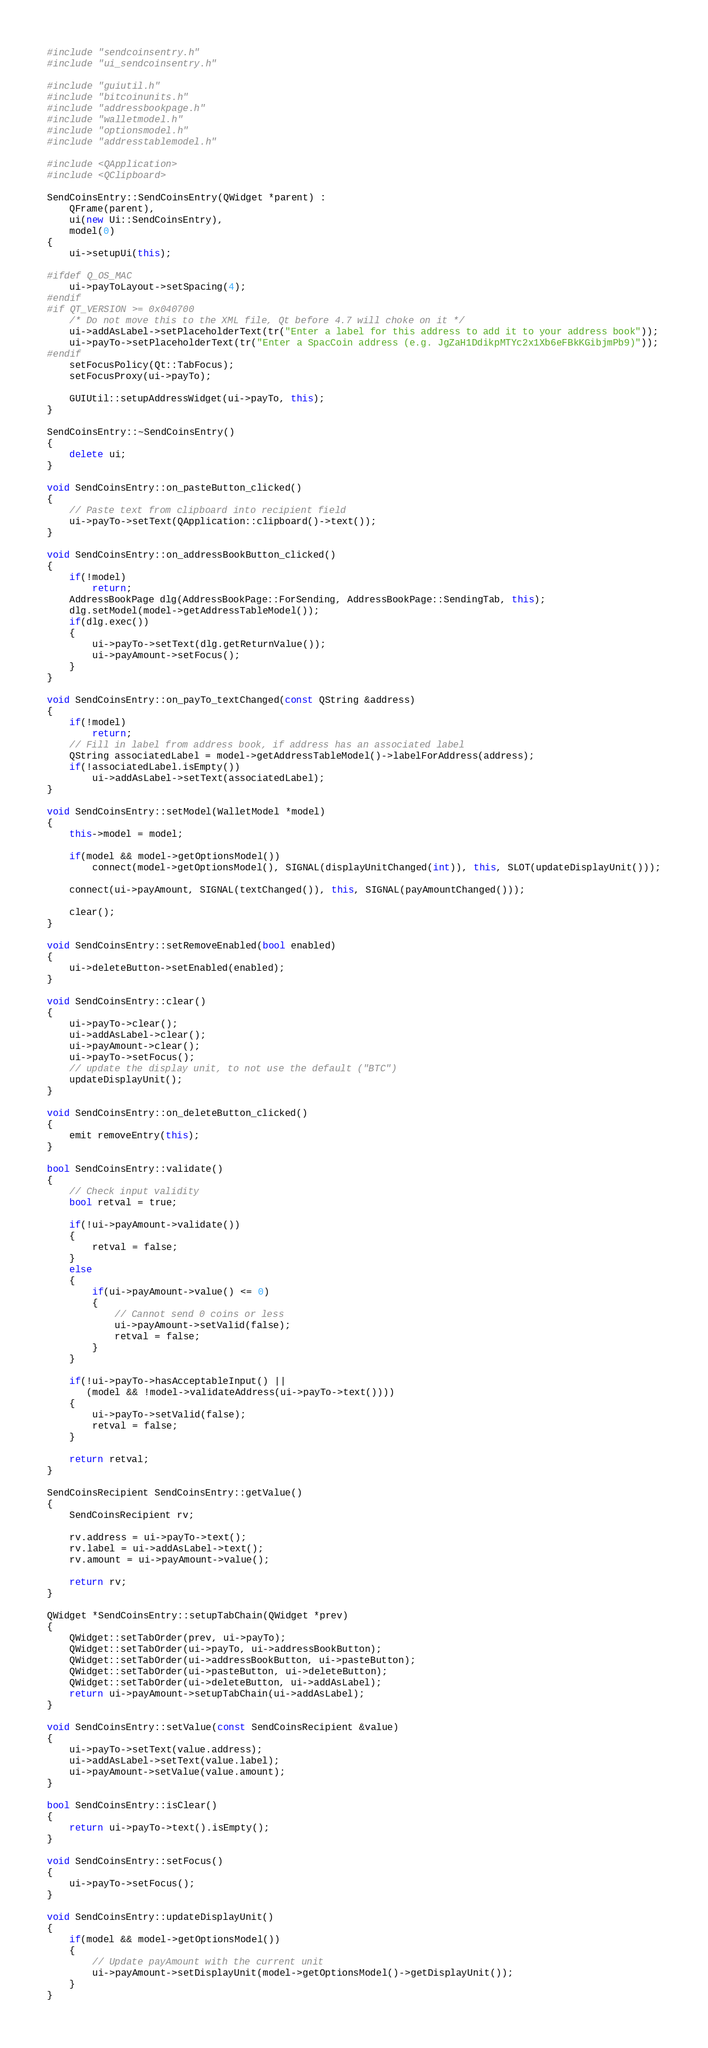Convert code to text. <code><loc_0><loc_0><loc_500><loc_500><_C++_>#include "sendcoinsentry.h"
#include "ui_sendcoinsentry.h"

#include "guiutil.h"
#include "bitcoinunits.h"
#include "addressbookpage.h"
#include "walletmodel.h"
#include "optionsmodel.h"
#include "addresstablemodel.h"

#include <QApplication>
#include <QClipboard>

SendCoinsEntry::SendCoinsEntry(QWidget *parent) :
    QFrame(parent),
    ui(new Ui::SendCoinsEntry),
    model(0)
{
    ui->setupUi(this);

#ifdef Q_OS_MAC
    ui->payToLayout->setSpacing(4);
#endif
#if QT_VERSION >= 0x040700
    /* Do not move this to the XML file, Qt before 4.7 will choke on it */
    ui->addAsLabel->setPlaceholderText(tr("Enter a label for this address to add it to your address book"));
    ui->payTo->setPlaceholderText(tr("Enter a SpacCoin address (e.g. JgZaH1DdikpMTYc2x1Xb6eFBkKGibjmPb9)"));
#endif
    setFocusPolicy(Qt::TabFocus);
    setFocusProxy(ui->payTo);

    GUIUtil::setupAddressWidget(ui->payTo, this);
}

SendCoinsEntry::~SendCoinsEntry()
{
    delete ui;
}

void SendCoinsEntry::on_pasteButton_clicked()
{
    // Paste text from clipboard into recipient field
    ui->payTo->setText(QApplication::clipboard()->text());
}

void SendCoinsEntry::on_addressBookButton_clicked()
{
    if(!model)
        return;
    AddressBookPage dlg(AddressBookPage::ForSending, AddressBookPage::SendingTab, this);
    dlg.setModel(model->getAddressTableModel());
    if(dlg.exec())
    {
        ui->payTo->setText(dlg.getReturnValue());
        ui->payAmount->setFocus();
    }
}

void SendCoinsEntry::on_payTo_textChanged(const QString &address)
{
    if(!model)
        return;
    // Fill in label from address book, if address has an associated label
    QString associatedLabel = model->getAddressTableModel()->labelForAddress(address);
    if(!associatedLabel.isEmpty())
        ui->addAsLabel->setText(associatedLabel);
}

void SendCoinsEntry::setModel(WalletModel *model)
{
    this->model = model;

    if(model && model->getOptionsModel())
        connect(model->getOptionsModel(), SIGNAL(displayUnitChanged(int)), this, SLOT(updateDisplayUnit()));

    connect(ui->payAmount, SIGNAL(textChanged()), this, SIGNAL(payAmountChanged()));

    clear();
}

void SendCoinsEntry::setRemoveEnabled(bool enabled)
{
    ui->deleteButton->setEnabled(enabled);
}

void SendCoinsEntry::clear()
{
    ui->payTo->clear();
    ui->addAsLabel->clear();
    ui->payAmount->clear();
    ui->payTo->setFocus();
    // update the display unit, to not use the default ("BTC")
    updateDisplayUnit();
}

void SendCoinsEntry::on_deleteButton_clicked()
{
    emit removeEntry(this);
}

bool SendCoinsEntry::validate()
{
    // Check input validity
    bool retval = true;

    if(!ui->payAmount->validate())
    {
        retval = false;
    }
    else
    {
        if(ui->payAmount->value() <= 0)
        {
            // Cannot send 0 coins or less
            ui->payAmount->setValid(false);
            retval = false;
        }
    }

    if(!ui->payTo->hasAcceptableInput() ||
       (model && !model->validateAddress(ui->payTo->text())))
    {
        ui->payTo->setValid(false);
        retval = false;
    }

    return retval;
}

SendCoinsRecipient SendCoinsEntry::getValue()
{
    SendCoinsRecipient rv;

    rv.address = ui->payTo->text();
    rv.label = ui->addAsLabel->text();
    rv.amount = ui->payAmount->value();

    return rv;
}

QWidget *SendCoinsEntry::setupTabChain(QWidget *prev)
{
    QWidget::setTabOrder(prev, ui->payTo);
    QWidget::setTabOrder(ui->payTo, ui->addressBookButton);
    QWidget::setTabOrder(ui->addressBookButton, ui->pasteButton);
    QWidget::setTabOrder(ui->pasteButton, ui->deleteButton);
    QWidget::setTabOrder(ui->deleteButton, ui->addAsLabel);
    return ui->payAmount->setupTabChain(ui->addAsLabel);
}

void SendCoinsEntry::setValue(const SendCoinsRecipient &value)
{
    ui->payTo->setText(value.address);
    ui->addAsLabel->setText(value.label);
    ui->payAmount->setValue(value.amount);
}

bool SendCoinsEntry::isClear()
{
    return ui->payTo->text().isEmpty();
}

void SendCoinsEntry::setFocus()
{
    ui->payTo->setFocus();
}

void SendCoinsEntry::updateDisplayUnit()
{
    if(model && model->getOptionsModel())
    {
        // Update payAmount with the current unit
        ui->payAmount->setDisplayUnit(model->getOptionsModel()->getDisplayUnit());
    }
}
</code> 